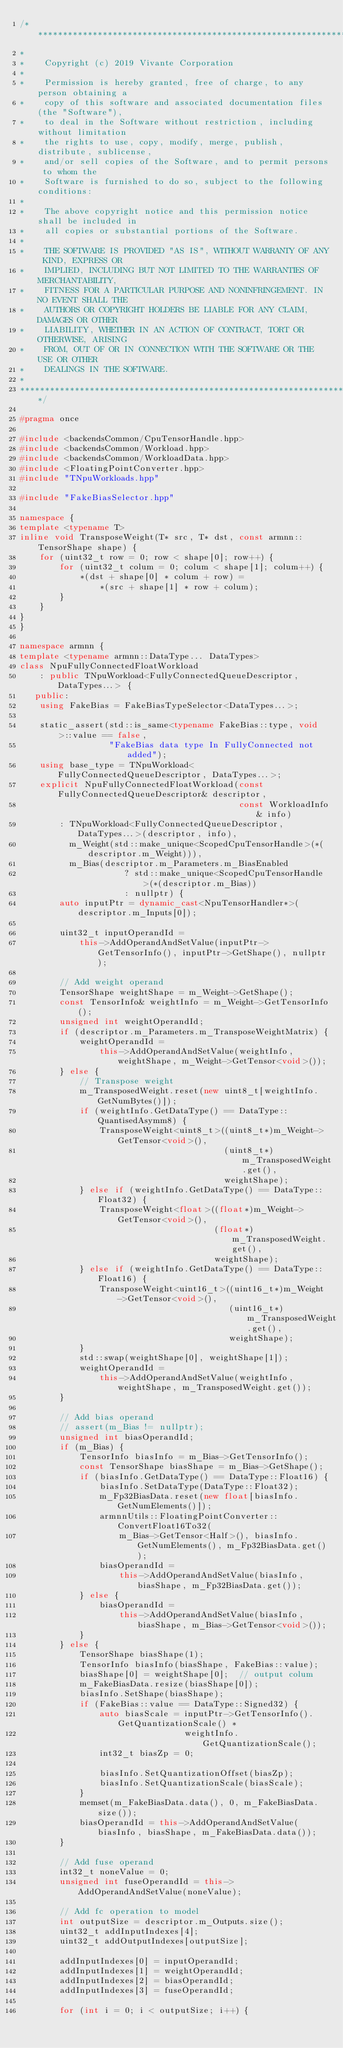Convert code to text. <code><loc_0><loc_0><loc_500><loc_500><_C++_>/****************************************************************************
*
*    Copyright (c) 2019 Vivante Corporation
*
*    Permission is hereby granted, free of charge, to any person obtaining a
*    copy of this software and associated documentation files (the "Software"),
*    to deal in the Software without restriction, including without limitation
*    the rights to use, copy, modify, merge, publish, distribute, sublicense,
*    and/or sell copies of the Software, and to permit persons to whom the
*    Software is furnished to do so, subject to the following conditions:
*
*    The above copyright notice and this permission notice shall be included in
*    all copies or substantial portions of the Software.
*
*    THE SOFTWARE IS PROVIDED "AS IS", WITHOUT WARRANTY OF ANY KIND, EXPRESS OR
*    IMPLIED, INCLUDING BUT NOT LIMITED TO THE WARRANTIES OF MERCHANTABILITY,
*    FITNESS FOR A PARTICULAR PURPOSE AND NONINFRINGEMENT. IN NO EVENT SHALL THE
*    AUTHORS OR COPYRIGHT HOLDERS BE LIABLE FOR ANY CLAIM, DAMAGES OR OTHER
*    LIABILITY, WHETHER IN AN ACTION OF CONTRACT, TORT OR OTHERWISE, ARISING
*    FROM, OUT OF OR IN CONNECTION WITH THE SOFTWARE OR THE USE OR OTHER
*    DEALINGS IN THE SOFTWARE.
*
*****************************************************************************/

#pragma once

#include <backendsCommon/CpuTensorHandle.hpp>
#include <backendsCommon/Workload.hpp>
#include <backendsCommon/WorkloadData.hpp>
#include <FloatingPointConverter.hpp>
#include "TNpuWorkloads.hpp"

#include "FakeBiasSelector.hpp"

namespace {
template <typename T>
inline void TransposeWeight(T* src, T* dst, const armnn::TensorShape shape) {
    for (uint32_t row = 0; row < shape[0]; row++) {
        for (uint32_t colum = 0; colum < shape[1]; colum++) {
            *(dst + shape[0] * colum + row) =
                *(src + shape[1] * row + colum);
        }
    }
}
}

namespace armnn {
template <typename armnn::DataType... DataTypes>
class NpuFullyConnectedFloatWorkload
    : public TNpuWorkload<FullyConnectedQueueDescriptor, DataTypes...> {
   public:
    using FakeBias = FakeBiasTypeSelector<DataTypes...>;

    static_assert(std::is_same<typename FakeBias::type, void>::value == false,
                  "FakeBias data type In FullyConnected not added");
    using base_type = TNpuWorkload<FullyConnectedQueueDescriptor, DataTypes...>;
    explicit NpuFullyConnectedFloatWorkload(const FullyConnectedQueueDescriptor& descriptor,
                                            const WorkloadInfo& info)
        : TNpuWorkload<FullyConnectedQueueDescriptor, DataTypes...>(descriptor, info),
          m_Weight(std::make_unique<ScopedCpuTensorHandle>(*(descriptor.m_Weight))),
          m_Bias(descriptor.m_Parameters.m_BiasEnabled
                     ? std::make_unique<ScopedCpuTensorHandle>(*(descriptor.m_Bias))
                     : nullptr) {
        auto inputPtr = dynamic_cast<NpuTensorHandler*>(descriptor.m_Inputs[0]);

        uint32_t inputOperandId =
            this->AddOperandAndSetValue(inputPtr->GetTensorInfo(), inputPtr->GetShape(), nullptr);

        // Add weight operand
        TensorShape weightShape = m_Weight->GetShape();
        const TensorInfo& weightInfo = m_Weight->GetTensorInfo();
        unsigned int weightOperandId;
        if (descriptor.m_Parameters.m_TransposeWeightMatrix) {
            weightOperandId =
                this->AddOperandAndSetValue(weightInfo, weightShape, m_Weight->GetTensor<void>());
        } else {
            // Transpose weight
            m_TransposedWeight.reset(new uint8_t[weightInfo.GetNumBytes()]);
            if (weightInfo.GetDataType() == DataType::QuantisedAsymm8) {
                TransposeWeight<uint8_t>((uint8_t*)m_Weight->GetTensor<void>(),
                                         (uint8_t*)m_TransposedWeight.get(),
                                         weightShape);
            } else if (weightInfo.GetDataType() == DataType::Float32) {
                TransposeWeight<float>((float*)m_Weight->GetTensor<void>(),
                                       (float*)m_TransposedWeight.get(),
                                       weightShape);
            } else if (weightInfo.GetDataType() == DataType::Float16) {
                TransposeWeight<uint16_t>((uint16_t*)m_Weight->GetTensor<void>(),
                                          (uint16_t*)m_TransposedWeight.get(),
                                          weightShape);
            }
            std::swap(weightShape[0], weightShape[1]);
            weightOperandId =
                this->AddOperandAndSetValue(weightInfo, weightShape, m_TransposedWeight.get());
        }

        // Add bias operand
        // assert(m_Bias != nullptr);
        unsigned int biasOperandId;
        if (m_Bias) {
            TensorInfo biasInfo = m_Bias->GetTensorInfo();
            const TensorShape biasShape = m_Bias->GetShape();
            if (biasInfo.GetDataType() == DataType::Float16) {
                biasInfo.SetDataType(DataType::Float32);
                m_Fp32BiasData.reset(new float[biasInfo.GetNumElements()]);
                armnnUtils::FloatingPointConverter::ConvertFloat16To32(
                    m_Bias->GetTensor<Half>(), biasInfo.GetNumElements(), m_Fp32BiasData.get());
                biasOperandId =
                    this->AddOperandAndSetValue(biasInfo, biasShape, m_Fp32BiasData.get());
            } else {
                biasOperandId =
                    this->AddOperandAndSetValue(biasInfo, biasShape, m_Bias->GetTensor<void>());
            }
        } else {
            TensorShape biasShape(1);
            TensorInfo biasInfo(biasShape, FakeBias::value);
            biasShape[0] = weightShape[0];  // output colum
            m_FakeBiasData.resize(biasShape[0]);
            biasInfo.SetShape(biasShape);
            if (FakeBias::value == DataType::Signed32) {
                auto biasScale = inputPtr->GetTensorInfo().GetQuantizationScale() *
                                 weightInfo.GetQuantizationScale();
                int32_t biasZp = 0;

                biasInfo.SetQuantizationOffset(biasZp);
                biasInfo.SetQuantizationScale(biasScale);
            }
            memset(m_FakeBiasData.data(), 0, m_FakeBiasData.size());
            biasOperandId = this->AddOperandAndSetValue(biasInfo, biasShape, m_FakeBiasData.data());
        }

        // Add fuse operand
        int32_t noneValue = 0;
        unsigned int fuseOperandId = this->AddOperandAndSetValue(noneValue);

        // Add fc operation to model
        int outputSize = descriptor.m_Outputs.size();
        uint32_t addInputIndexes[4];
        uint32_t addOutputIndexes[outputSize];

        addInputIndexes[0] = inputOperandId;
        addInputIndexes[1] = weightOperandId;
        addInputIndexes[2] = biasOperandId;
        addInputIndexes[3] = fuseOperandId;

        for (int i = 0; i < outputSize; i++) {</code> 